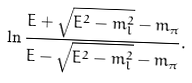Convert formula to latex. <formula><loc_0><loc_0><loc_500><loc_500>\ln { \frac { E + \sqrt { E ^ { 2 } - m _ { l } ^ { 2 } } - m _ { \pi } } { E - \sqrt { E ^ { 2 } - m _ { l } ^ { 2 } } - m _ { \pi } } } .</formula> 